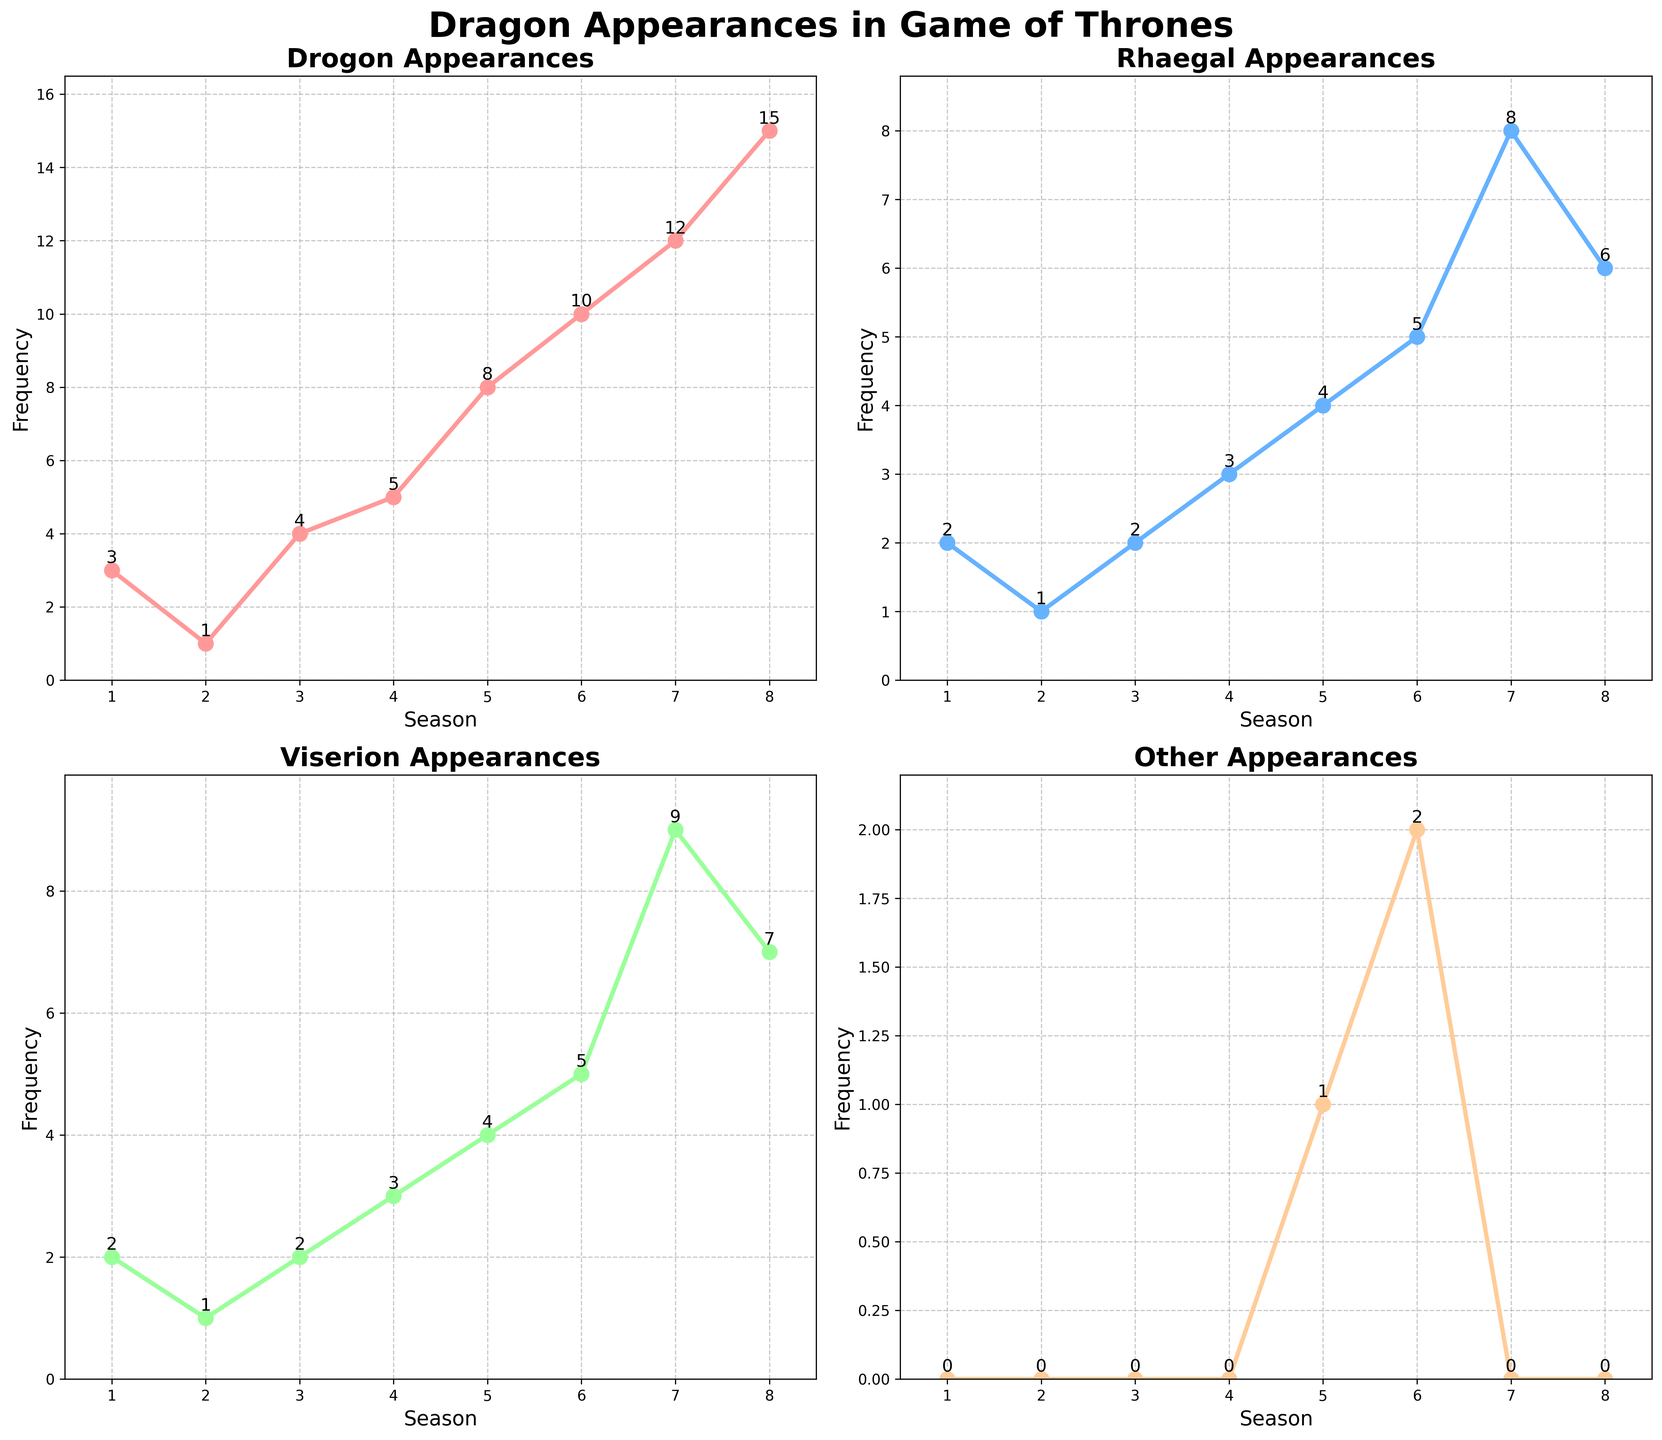How many times did Drogon appear in Season 5? To find Drogon's appearances in Season 5, we look at the 'Drogon' subplot and locate the point corresponding to Season 5. The y-value of this point gives the frequency of appearances.
Answer: 8 Which dragon had the most appearances overall throughout all the seasons? To answer this, compare the totals of each dragon's appearances from all seasons. The dragon with the highest total is the one with the most appearances.
Answer: Drogon What is the difference between the maximum and minimum frequencies of Rhaegal's appearances? Look at the 'Rhaegal' subplot. The maximum frequency is 8 (Season 7) and the minimum is 1 (Season 2). The difference is calculated by subtracting the minimum from the maximum.
Answer: 7 Which season saw the highest cumulative appearances of all dragons combined? Calculate the sum of appearances for all dragons in each season and compare to find the highest. Season 8 has the highest combined appearances (15+6+7+0=28).
Answer: Season 8 How does the frequency of Viserion's appearances in Season 6 compare to Season 7? Find the values of Viserion's appearances in Seasons 6 and 7 from the subplot. Season 6 has a frequency of 5 and Season 7 has 9. 9 is greater than 5.
Answer: Season 7 Did 'Other' dragons appear more frequently in any season compared to the main dragons? 'Other' dragons only appeared in two seasons with frequencies 1 (Season 5) and 2 (Season 6). All main dragons appeared more frequently in the seasons.
Answer: No What is the combined frequency of Drogon and Viserion's appearances in Season 4? In Season 4, Drogon appeared 5 times and Viserion appeared 3 times. The combined frequency is 5 + 3.
Answer: 8 Which dragon had the least incremental increase in appearances from Season 1 to 2? Look at the increase from Season 1 to 2 for each dragon: 
Drogon (3 to 1): -2 
Rhaegal (2 to 1): -1 
Viserion (2 to 1): -1 
'Other' (0 to 0): 0 
The least incremental increase is 'Other' with no change.
Answer: 'Other' How many total appearances did Rhaegal have in odd-numbered seasons? Add Rhaegal's appearances in Seasons 1, 3, 5, and 7: 2 (S1) + 2 (S3) + 4 (S5) + 8 (S7).
Answer: 16 Which dragon shows the steepest increase in appearances between any two consecutive seasons? Compare the slopes (rates of change between consecutive seasons) for each dragon. Season 7 to 8 for Drogon shows an increase from 12 to 15, the steepest change of 3.
Answer: Drogon 